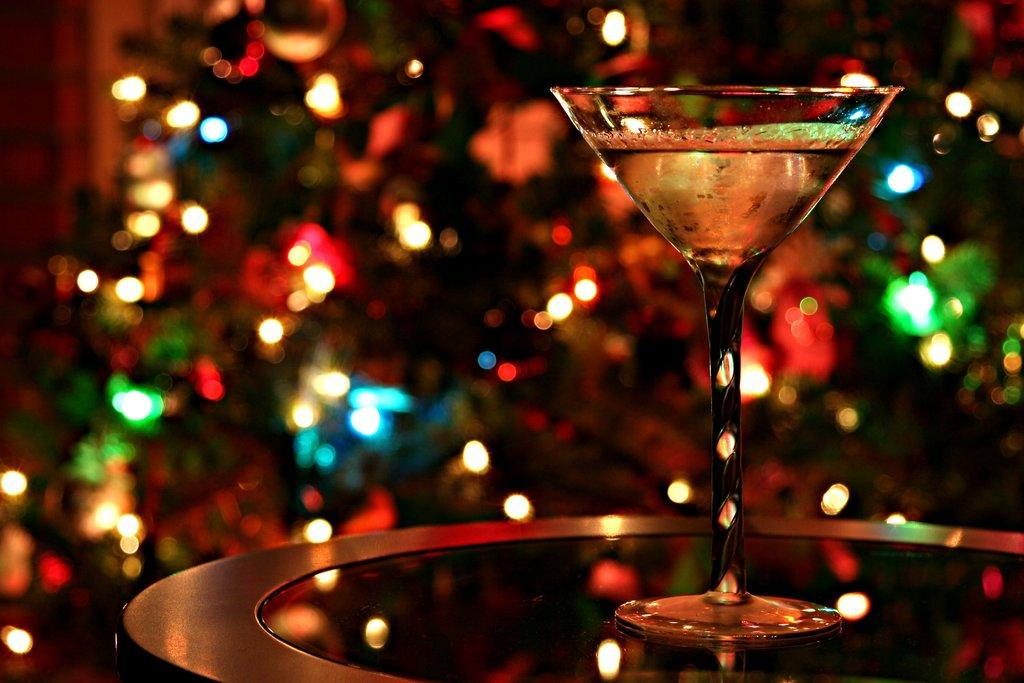What piece of furniture is present in the image? There is a table in the image. What object is placed on the table? There is a glass on the table. Can you describe the background of the image? The background of the image is blurry. What is the weight of the glass in the image? The weight of the glass cannot be determined from the image alone, as it depends on the size and material of the glass. 